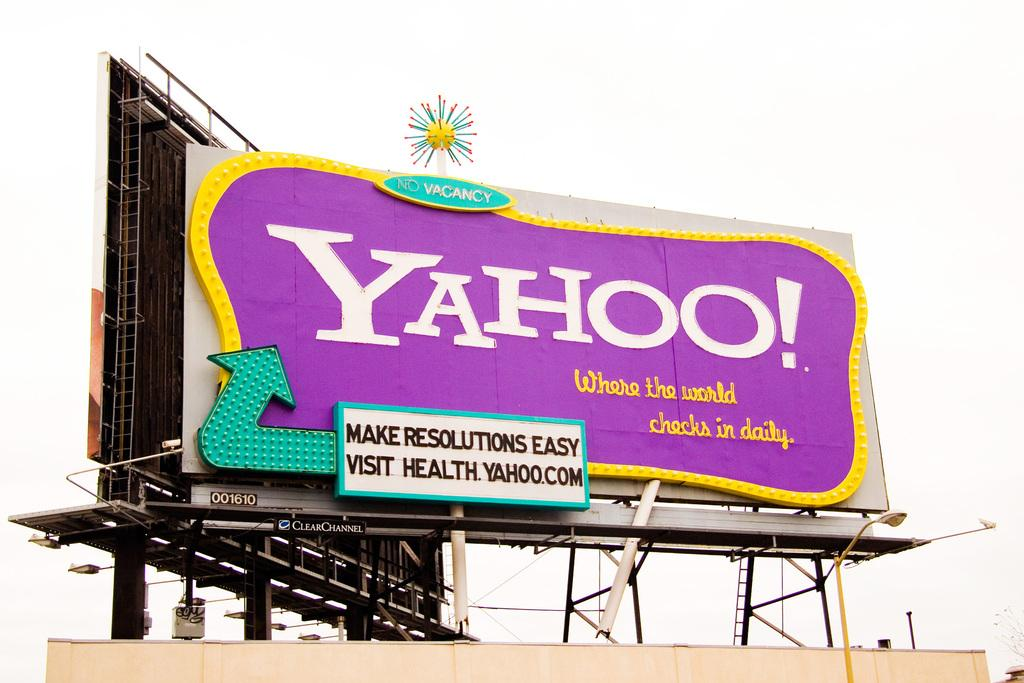<image>
Summarize the visual content of the image. You could visit health.yahoo.com to make resolutions easy, according to this billboard. 